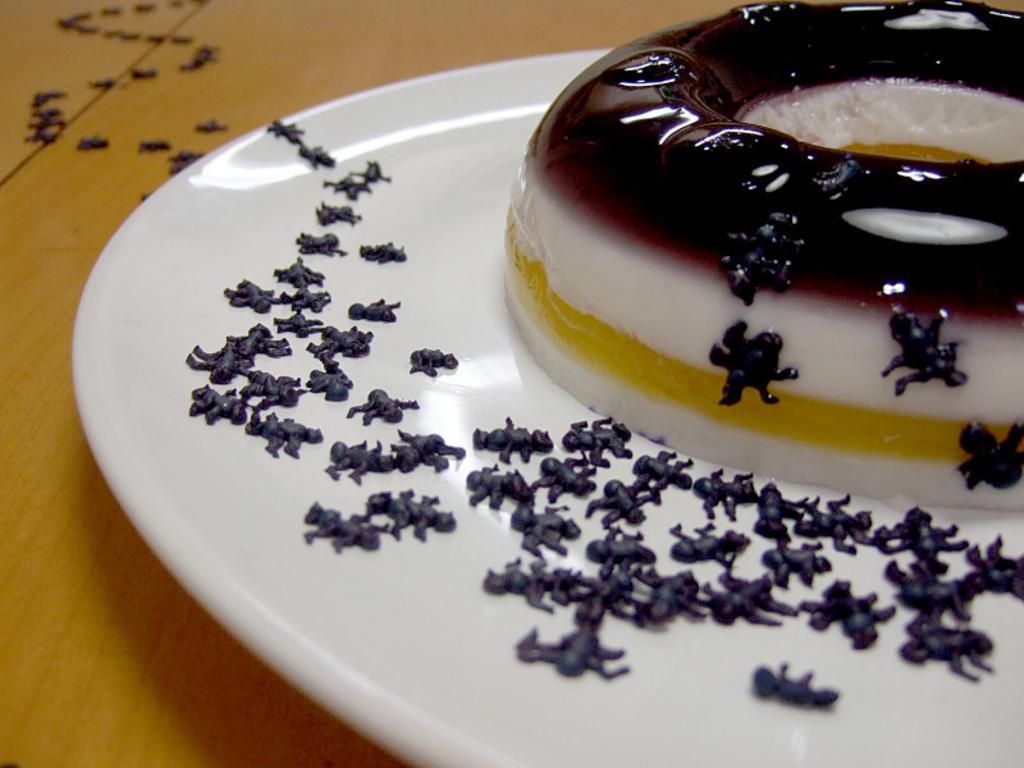In one or two sentences, can you explain what this image depicts? In this picture we can see a wooden surface, white plate and the food. 